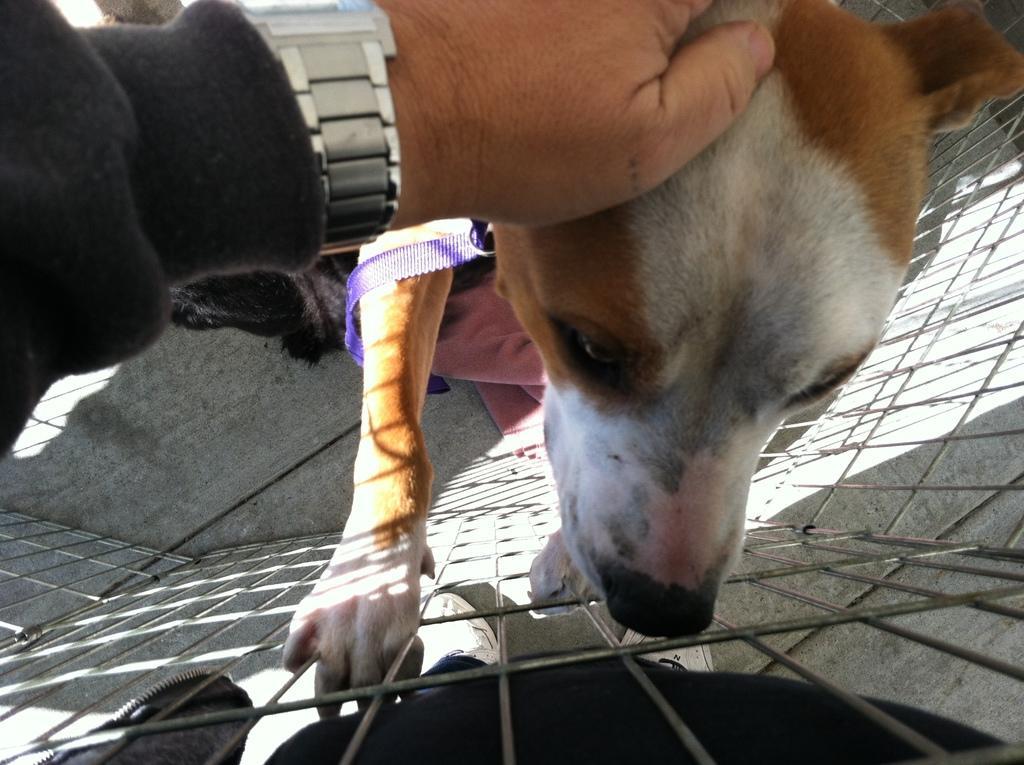Please provide a concise description of this image. In this image I can see a white and brown color top. On the left side there is the hand of a human with wrist watch and a coat. This is an iron grill at the bottom. 